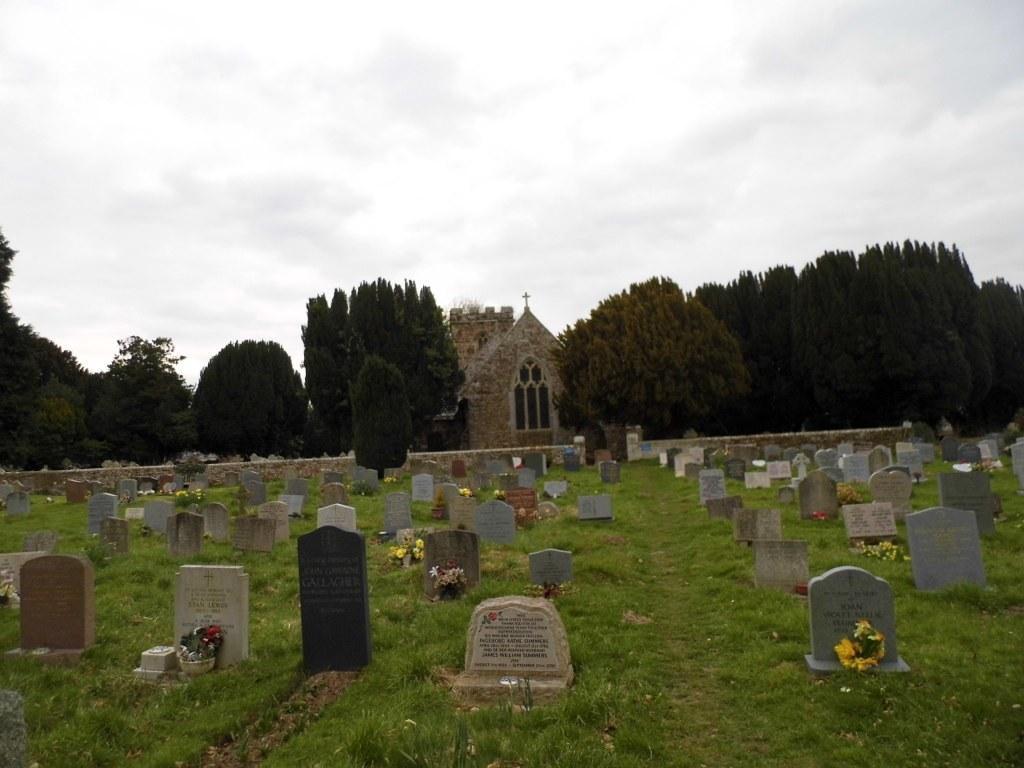In one or two sentences, can you explain what this image depicts? In this image I can see the cemetery and number of tombstones which are white, black and brown in color and I can see few flower bouquets in front of them. In the background I can see few trees, a building and the sky. 